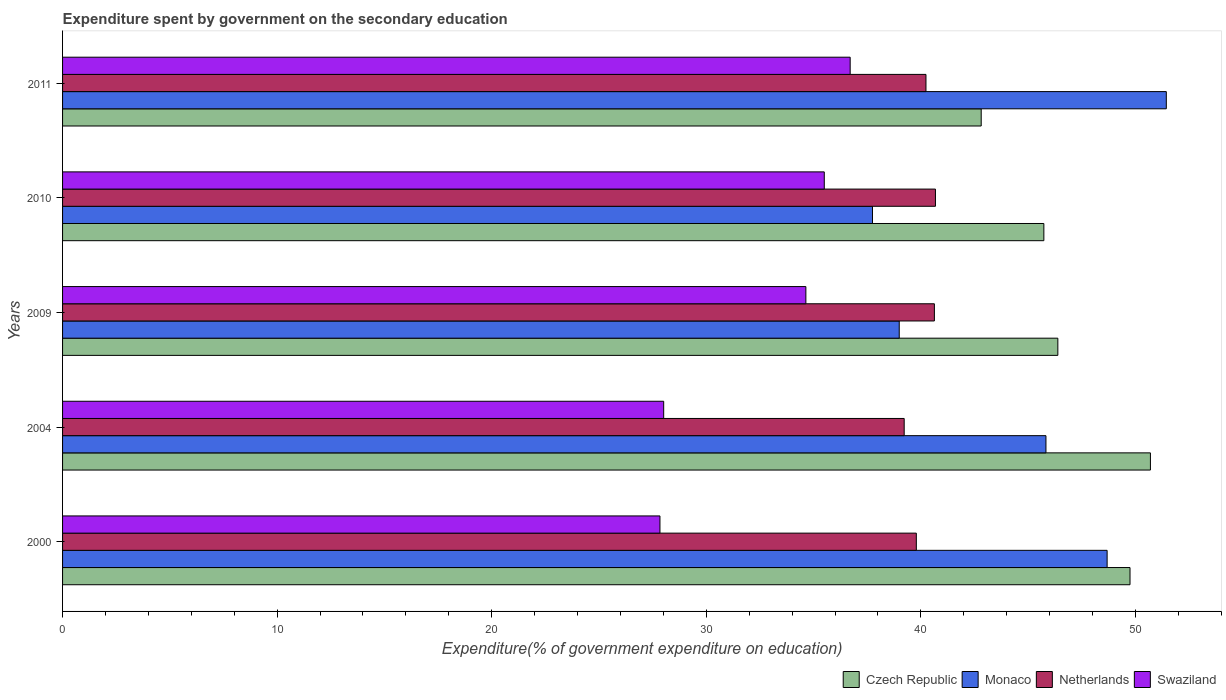How many different coloured bars are there?
Provide a succinct answer. 4. How many groups of bars are there?
Your answer should be compact. 5. Are the number of bars per tick equal to the number of legend labels?
Give a very brief answer. Yes. Are the number of bars on each tick of the Y-axis equal?
Keep it short and to the point. Yes. What is the label of the 2nd group of bars from the top?
Offer a very short reply. 2010. What is the expenditure spent by government on the secondary education in Czech Republic in 2011?
Your answer should be compact. 42.81. Across all years, what is the maximum expenditure spent by government on the secondary education in Netherlands?
Give a very brief answer. 40.68. Across all years, what is the minimum expenditure spent by government on the secondary education in Swaziland?
Your answer should be compact. 27.84. What is the total expenditure spent by government on the secondary education in Netherlands in the graph?
Provide a succinct answer. 200.57. What is the difference between the expenditure spent by government on the secondary education in Monaco in 2004 and that in 2010?
Ensure brevity in your answer.  8.08. What is the difference between the expenditure spent by government on the secondary education in Netherlands in 2004 and the expenditure spent by government on the secondary education in Monaco in 2009?
Make the answer very short. 0.23. What is the average expenditure spent by government on the secondary education in Czech Republic per year?
Make the answer very short. 47.08. In the year 2004, what is the difference between the expenditure spent by government on the secondary education in Czech Republic and expenditure spent by government on the secondary education in Swaziland?
Provide a short and direct response. 22.68. What is the ratio of the expenditure spent by government on the secondary education in Monaco in 2004 to that in 2009?
Keep it short and to the point. 1.18. Is the expenditure spent by government on the secondary education in Netherlands in 2000 less than that in 2004?
Ensure brevity in your answer.  No. Is the difference between the expenditure spent by government on the secondary education in Czech Republic in 2010 and 2011 greater than the difference between the expenditure spent by government on the secondary education in Swaziland in 2010 and 2011?
Provide a short and direct response. Yes. What is the difference between the highest and the second highest expenditure spent by government on the secondary education in Swaziland?
Offer a very short reply. 1.21. What is the difference between the highest and the lowest expenditure spent by government on the secondary education in Swaziland?
Make the answer very short. 8.87. In how many years, is the expenditure spent by government on the secondary education in Swaziland greater than the average expenditure spent by government on the secondary education in Swaziland taken over all years?
Make the answer very short. 3. Is the sum of the expenditure spent by government on the secondary education in Monaco in 2000 and 2004 greater than the maximum expenditure spent by government on the secondary education in Netherlands across all years?
Make the answer very short. Yes. Is it the case that in every year, the sum of the expenditure spent by government on the secondary education in Netherlands and expenditure spent by government on the secondary education in Czech Republic is greater than the sum of expenditure spent by government on the secondary education in Monaco and expenditure spent by government on the secondary education in Swaziland?
Keep it short and to the point. Yes. What does the 1st bar from the top in 2011 represents?
Offer a terse response. Swaziland. What does the 1st bar from the bottom in 2004 represents?
Provide a succinct answer. Czech Republic. How many bars are there?
Ensure brevity in your answer.  20. Are all the bars in the graph horizontal?
Offer a very short reply. Yes. What is the difference between two consecutive major ticks on the X-axis?
Ensure brevity in your answer.  10. How many legend labels are there?
Provide a short and direct response. 4. How are the legend labels stacked?
Ensure brevity in your answer.  Horizontal. What is the title of the graph?
Your answer should be compact. Expenditure spent by government on the secondary education. Does "Canada" appear as one of the legend labels in the graph?
Provide a succinct answer. No. What is the label or title of the X-axis?
Provide a short and direct response. Expenditure(% of government expenditure on education). What is the Expenditure(% of government expenditure on education) of Czech Republic in 2000?
Your answer should be compact. 49.75. What is the Expenditure(% of government expenditure on education) in Monaco in 2000?
Give a very brief answer. 48.68. What is the Expenditure(% of government expenditure on education) in Netherlands in 2000?
Provide a short and direct response. 39.79. What is the Expenditure(% of government expenditure on education) of Swaziland in 2000?
Provide a short and direct response. 27.84. What is the Expenditure(% of government expenditure on education) of Czech Republic in 2004?
Provide a succinct answer. 50.7. What is the Expenditure(% of government expenditure on education) of Monaco in 2004?
Ensure brevity in your answer.  45.83. What is the Expenditure(% of government expenditure on education) of Netherlands in 2004?
Your answer should be very brief. 39.22. What is the Expenditure(% of government expenditure on education) of Swaziland in 2004?
Provide a succinct answer. 28.02. What is the Expenditure(% of government expenditure on education) in Czech Republic in 2009?
Your response must be concise. 46.39. What is the Expenditure(% of government expenditure on education) of Monaco in 2009?
Offer a terse response. 38.99. What is the Expenditure(% of government expenditure on education) of Netherlands in 2009?
Give a very brief answer. 40.63. What is the Expenditure(% of government expenditure on education) of Swaziland in 2009?
Your response must be concise. 34.64. What is the Expenditure(% of government expenditure on education) in Czech Republic in 2010?
Give a very brief answer. 45.73. What is the Expenditure(% of government expenditure on education) in Monaco in 2010?
Provide a short and direct response. 37.75. What is the Expenditure(% of government expenditure on education) in Netherlands in 2010?
Keep it short and to the point. 40.68. What is the Expenditure(% of government expenditure on education) in Swaziland in 2010?
Ensure brevity in your answer.  35.5. What is the Expenditure(% of government expenditure on education) in Czech Republic in 2011?
Provide a short and direct response. 42.81. What is the Expenditure(% of government expenditure on education) in Monaco in 2011?
Give a very brief answer. 51.44. What is the Expenditure(% of government expenditure on education) of Netherlands in 2011?
Offer a very short reply. 40.24. What is the Expenditure(% of government expenditure on education) of Swaziland in 2011?
Your answer should be very brief. 36.71. Across all years, what is the maximum Expenditure(% of government expenditure on education) in Czech Republic?
Your answer should be compact. 50.7. Across all years, what is the maximum Expenditure(% of government expenditure on education) of Monaco?
Ensure brevity in your answer.  51.44. Across all years, what is the maximum Expenditure(% of government expenditure on education) in Netherlands?
Provide a succinct answer. 40.68. Across all years, what is the maximum Expenditure(% of government expenditure on education) of Swaziland?
Give a very brief answer. 36.71. Across all years, what is the minimum Expenditure(% of government expenditure on education) of Czech Republic?
Give a very brief answer. 42.81. Across all years, what is the minimum Expenditure(% of government expenditure on education) in Monaco?
Make the answer very short. 37.75. Across all years, what is the minimum Expenditure(% of government expenditure on education) of Netherlands?
Provide a short and direct response. 39.22. Across all years, what is the minimum Expenditure(% of government expenditure on education) in Swaziland?
Keep it short and to the point. 27.84. What is the total Expenditure(% of government expenditure on education) in Czech Republic in the graph?
Provide a short and direct response. 235.38. What is the total Expenditure(% of government expenditure on education) in Monaco in the graph?
Your answer should be compact. 222.69. What is the total Expenditure(% of government expenditure on education) of Netherlands in the graph?
Provide a succinct answer. 200.57. What is the total Expenditure(% of government expenditure on education) in Swaziland in the graph?
Your answer should be very brief. 162.71. What is the difference between the Expenditure(% of government expenditure on education) in Czech Republic in 2000 and that in 2004?
Your answer should be very brief. -0.95. What is the difference between the Expenditure(% of government expenditure on education) in Monaco in 2000 and that in 2004?
Your answer should be compact. 2.85. What is the difference between the Expenditure(% of government expenditure on education) of Netherlands in 2000 and that in 2004?
Offer a terse response. 0.57. What is the difference between the Expenditure(% of government expenditure on education) of Swaziland in 2000 and that in 2004?
Ensure brevity in your answer.  -0.17. What is the difference between the Expenditure(% of government expenditure on education) in Czech Republic in 2000 and that in 2009?
Keep it short and to the point. 3.36. What is the difference between the Expenditure(% of government expenditure on education) of Monaco in 2000 and that in 2009?
Give a very brief answer. 9.69. What is the difference between the Expenditure(% of government expenditure on education) in Netherlands in 2000 and that in 2009?
Make the answer very short. -0.84. What is the difference between the Expenditure(% of government expenditure on education) in Swaziland in 2000 and that in 2009?
Offer a very short reply. -6.8. What is the difference between the Expenditure(% of government expenditure on education) of Czech Republic in 2000 and that in 2010?
Your answer should be compact. 4.02. What is the difference between the Expenditure(% of government expenditure on education) of Monaco in 2000 and that in 2010?
Offer a terse response. 10.94. What is the difference between the Expenditure(% of government expenditure on education) in Netherlands in 2000 and that in 2010?
Keep it short and to the point. -0.89. What is the difference between the Expenditure(% of government expenditure on education) of Swaziland in 2000 and that in 2010?
Keep it short and to the point. -7.66. What is the difference between the Expenditure(% of government expenditure on education) of Czech Republic in 2000 and that in 2011?
Your response must be concise. 6.94. What is the difference between the Expenditure(% of government expenditure on education) in Monaco in 2000 and that in 2011?
Offer a terse response. -2.76. What is the difference between the Expenditure(% of government expenditure on education) in Netherlands in 2000 and that in 2011?
Give a very brief answer. -0.45. What is the difference between the Expenditure(% of government expenditure on education) of Swaziland in 2000 and that in 2011?
Offer a very short reply. -8.87. What is the difference between the Expenditure(% of government expenditure on education) of Czech Republic in 2004 and that in 2009?
Give a very brief answer. 4.31. What is the difference between the Expenditure(% of government expenditure on education) in Monaco in 2004 and that in 2009?
Provide a succinct answer. 6.84. What is the difference between the Expenditure(% of government expenditure on education) of Netherlands in 2004 and that in 2009?
Keep it short and to the point. -1.41. What is the difference between the Expenditure(% of government expenditure on education) of Swaziland in 2004 and that in 2009?
Provide a short and direct response. -6.63. What is the difference between the Expenditure(% of government expenditure on education) of Czech Republic in 2004 and that in 2010?
Your answer should be very brief. 4.97. What is the difference between the Expenditure(% of government expenditure on education) in Monaco in 2004 and that in 2010?
Offer a terse response. 8.08. What is the difference between the Expenditure(% of government expenditure on education) of Netherlands in 2004 and that in 2010?
Your answer should be very brief. -1.46. What is the difference between the Expenditure(% of government expenditure on education) of Swaziland in 2004 and that in 2010?
Make the answer very short. -7.48. What is the difference between the Expenditure(% of government expenditure on education) of Czech Republic in 2004 and that in 2011?
Provide a succinct answer. 7.89. What is the difference between the Expenditure(% of government expenditure on education) of Monaco in 2004 and that in 2011?
Your answer should be compact. -5.61. What is the difference between the Expenditure(% of government expenditure on education) in Netherlands in 2004 and that in 2011?
Offer a terse response. -1.01. What is the difference between the Expenditure(% of government expenditure on education) of Swaziland in 2004 and that in 2011?
Offer a terse response. -8.69. What is the difference between the Expenditure(% of government expenditure on education) in Czech Republic in 2009 and that in 2010?
Make the answer very short. 0.65. What is the difference between the Expenditure(% of government expenditure on education) in Monaco in 2009 and that in 2010?
Give a very brief answer. 1.25. What is the difference between the Expenditure(% of government expenditure on education) in Netherlands in 2009 and that in 2010?
Provide a succinct answer. -0.05. What is the difference between the Expenditure(% of government expenditure on education) of Swaziland in 2009 and that in 2010?
Ensure brevity in your answer.  -0.86. What is the difference between the Expenditure(% of government expenditure on education) in Czech Republic in 2009 and that in 2011?
Give a very brief answer. 3.57. What is the difference between the Expenditure(% of government expenditure on education) of Monaco in 2009 and that in 2011?
Your answer should be very brief. -12.45. What is the difference between the Expenditure(% of government expenditure on education) of Netherlands in 2009 and that in 2011?
Keep it short and to the point. 0.39. What is the difference between the Expenditure(% of government expenditure on education) of Swaziland in 2009 and that in 2011?
Your response must be concise. -2.06. What is the difference between the Expenditure(% of government expenditure on education) of Czech Republic in 2010 and that in 2011?
Give a very brief answer. 2.92. What is the difference between the Expenditure(% of government expenditure on education) in Monaco in 2010 and that in 2011?
Make the answer very short. -13.69. What is the difference between the Expenditure(% of government expenditure on education) in Netherlands in 2010 and that in 2011?
Offer a terse response. 0.44. What is the difference between the Expenditure(% of government expenditure on education) of Swaziland in 2010 and that in 2011?
Ensure brevity in your answer.  -1.21. What is the difference between the Expenditure(% of government expenditure on education) in Czech Republic in 2000 and the Expenditure(% of government expenditure on education) in Monaco in 2004?
Your answer should be very brief. 3.92. What is the difference between the Expenditure(% of government expenditure on education) in Czech Republic in 2000 and the Expenditure(% of government expenditure on education) in Netherlands in 2004?
Offer a very short reply. 10.52. What is the difference between the Expenditure(% of government expenditure on education) in Czech Republic in 2000 and the Expenditure(% of government expenditure on education) in Swaziland in 2004?
Keep it short and to the point. 21.73. What is the difference between the Expenditure(% of government expenditure on education) of Monaco in 2000 and the Expenditure(% of government expenditure on education) of Netherlands in 2004?
Give a very brief answer. 9.46. What is the difference between the Expenditure(% of government expenditure on education) of Monaco in 2000 and the Expenditure(% of government expenditure on education) of Swaziland in 2004?
Provide a succinct answer. 20.67. What is the difference between the Expenditure(% of government expenditure on education) of Netherlands in 2000 and the Expenditure(% of government expenditure on education) of Swaziland in 2004?
Ensure brevity in your answer.  11.77. What is the difference between the Expenditure(% of government expenditure on education) in Czech Republic in 2000 and the Expenditure(% of government expenditure on education) in Monaco in 2009?
Provide a succinct answer. 10.76. What is the difference between the Expenditure(% of government expenditure on education) of Czech Republic in 2000 and the Expenditure(% of government expenditure on education) of Netherlands in 2009?
Give a very brief answer. 9.12. What is the difference between the Expenditure(% of government expenditure on education) of Czech Republic in 2000 and the Expenditure(% of government expenditure on education) of Swaziland in 2009?
Offer a very short reply. 15.11. What is the difference between the Expenditure(% of government expenditure on education) in Monaco in 2000 and the Expenditure(% of government expenditure on education) in Netherlands in 2009?
Keep it short and to the point. 8.05. What is the difference between the Expenditure(% of government expenditure on education) of Monaco in 2000 and the Expenditure(% of government expenditure on education) of Swaziland in 2009?
Your response must be concise. 14.04. What is the difference between the Expenditure(% of government expenditure on education) in Netherlands in 2000 and the Expenditure(% of government expenditure on education) in Swaziland in 2009?
Provide a succinct answer. 5.15. What is the difference between the Expenditure(% of government expenditure on education) in Czech Republic in 2000 and the Expenditure(% of government expenditure on education) in Monaco in 2010?
Provide a succinct answer. 12. What is the difference between the Expenditure(% of government expenditure on education) of Czech Republic in 2000 and the Expenditure(% of government expenditure on education) of Netherlands in 2010?
Provide a short and direct response. 9.07. What is the difference between the Expenditure(% of government expenditure on education) in Czech Republic in 2000 and the Expenditure(% of government expenditure on education) in Swaziland in 2010?
Make the answer very short. 14.25. What is the difference between the Expenditure(% of government expenditure on education) of Monaco in 2000 and the Expenditure(% of government expenditure on education) of Netherlands in 2010?
Offer a terse response. 8. What is the difference between the Expenditure(% of government expenditure on education) in Monaco in 2000 and the Expenditure(% of government expenditure on education) in Swaziland in 2010?
Provide a short and direct response. 13.18. What is the difference between the Expenditure(% of government expenditure on education) of Netherlands in 2000 and the Expenditure(% of government expenditure on education) of Swaziland in 2010?
Your answer should be compact. 4.29. What is the difference between the Expenditure(% of government expenditure on education) of Czech Republic in 2000 and the Expenditure(% of government expenditure on education) of Monaco in 2011?
Offer a terse response. -1.69. What is the difference between the Expenditure(% of government expenditure on education) of Czech Republic in 2000 and the Expenditure(% of government expenditure on education) of Netherlands in 2011?
Your response must be concise. 9.51. What is the difference between the Expenditure(% of government expenditure on education) in Czech Republic in 2000 and the Expenditure(% of government expenditure on education) in Swaziland in 2011?
Give a very brief answer. 13.04. What is the difference between the Expenditure(% of government expenditure on education) of Monaco in 2000 and the Expenditure(% of government expenditure on education) of Netherlands in 2011?
Make the answer very short. 8.44. What is the difference between the Expenditure(% of government expenditure on education) in Monaco in 2000 and the Expenditure(% of government expenditure on education) in Swaziland in 2011?
Offer a terse response. 11.98. What is the difference between the Expenditure(% of government expenditure on education) of Netherlands in 2000 and the Expenditure(% of government expenditure on education) of Swaziland in 2011?
Your response must be concise. 3.08. What is the difference between the Expenditure(% of government expenditure on education) in Czech Republic in 2004 and the Expenditure(% of government expenditure on education) in Monaco in 2009?
Your response must be concise. 11.71. What is the difference between the Expenditure(% of government expenditure on education) of Czech Republic in 2004 and the Expenditure(% of government expenditure on education) of Netherlands in 2009?
Make the answer very short. 10.07. What is the difference between the Expenditure(% of government expenditure on education) in Czech Republic in 2004 and the Expenditure(% of government expenditure on education) in Swaziland in 2009?
Give a very brief answer. 16.06. What is the difference between the Expenditure(% of government expenditure on education) in Monaco in 2004 and the Expenditure(% of government expenditure on education) in Netherlands in 2009?
Offer a very short reply. 5.2. What is the difference between the Expenditure(% of government expenditure on education) of Monaco in 2004 and the Expenditure(% of government expenditure on education) of Swaziland in 2009?
Provide a short and direct response. 11.19. What is the difference between the Expenditure(% of government expenditure on education) in Netherlands in 2004 and the Expenditure(% of government expenditure on education) in Swaziland in 2009?
Provide a short and direct response. 4.58. What is the difference between the Expenditure(% of government expenditure on education) of Czech Republic in 2004 and the Expenditure(% of government expenditure on education) of Monaco in 2010?
Provide a succinct answer. 12.95. What is the difference between the Expenditure(% of government expenditure on education) of Czech Republic in 2004 and the Expenditure(% of government expenditure on education) of Netherlands in 2010?
Keep it short and to the point. 10.02. What is the difference between the Expenditure(% of government expenditure on education) of Czech Republic in 2004 and the Expenditure(% of government expenditure on education) of Swaziland in 2010?
Your response must be concise. 15.2. What is the difference between the Expenditure(% of government expenditure on education) in Monaco in 2004 and the Expenditure(% of government expenditure on education) in Netherlands in 2010?
Give a very brief answer. 5.15. What is the difference between the Expenditure(% of government expenditure on education) in Monaco in 2004 and the Expenditure(% of government expenditure on education) in Swaziland in 2010?
Your answer should be compact. 10.33. What is the difference between the Expenditure(% of government expenditure on education) in Netherlands in 2004 and the Expenditure(% of government expenditure on education) in Swaziland in 2010?
Your answer should be very brief. 3.72. What is the difference between the Expenditure(% of government expenditure on education) in Czech Republic in 2004 and the Expenditure(% of government expenditure on education) in Monaco in 2011?
Your response must be concise. -0.74. What is the difference between the Expenditure(% of government expenditure on education) of Czech Republic in 2004 and the Expenditure(% of government expenditure on education) of Netherlands in 2011?
Your response must be concise. 10.46. What is the difference between the Expenditure(% of government expenditure on education) in Czech Republic in 2004 and the Expenditure(% of government expenditure on education) in Swaziland in 2011?
Offer a very short reply. 13.99. What is the difference between the Expenditure(% of government expenditure on education) of Monaco in 2004 and the Expenditure(% of government expenditure on education) of Netherlands in 2011?
Make the answer very short. 5.59. What is the difference between the Expenditure(% of government expenditure on education) in Monaco in 2004 and the Expenditure(% of government expenditure on education) in Swaziland in 2011?
Offer a very short reply. 9.12. What is the difference between the Expenditure(% of government expenditure on education) of Netherlands in 2004 and the Expenditure(% of government expenditure on education) of Swaziland in 2011?
Provide a succinct answer. 2.52. What is the difference between the Expenditure(% of government expenditure on education) in Czech Republic in 2009 and the Expenditure(% of government expenditure on education) in Monaco in 2010?
Offer a very short reply. 8.64. What is the difference between the Expenditure(% of government expenditure on education) of Czech Republic in 2009 and the Expenditure(% of government expenditure on education) of Netherlands in 2010?
Offer a terse response. 5.7. What is the difference between the Expenditure(% of government expenditure on education) of Czech Republic in 2009 and the Expenditure(% of government expenditure on education) of Swaziland in 2010?
Ensure brevity in your answer.  10.89. What is the difference between the Expenditure(% of government expenditure on education) in Monaco in 2009 and the Expenditure(% of government expenditure on education) in Netherlands in 2010?
Your answer should be very brief. -1.69. What is the difference between the Expenditure(% of government expenditure on education) of Monaco in 2009 and the Expenditure(% of government expenditure on education) of Swaziland in 2010?
Make the answer very short. 3.49. What is the difference between the Expenditure(% of government expenditure on education) of Netherlands in 2009 and the Expenditure(% of government expenditure on education) of Swaziland in 2010?
Your answer should be very brief. 5.13. What is the difference between the Expenditure(% of government expenditure on education) of Czech Republic in 2009 and the Expenditure(% of government expenditure on education) of Monaco in 2011?
Your answer should be very brief. -5.05. What is the difference between the Expenditure(% of government expenditure on education) in Czech Republic in 2009 and the Expenditure(% of government expenditure on education) in Netherlands in 2011?
Your answer should be very brief. 6.15. What is the difference between the Expenditure(% of government expenditure on education) of Czech Republic in 2009 and the Expenditure(% of government expenditure on education) of Swaziland in 2011?
Ensure brevity in your answer.  9.68. What is the difference between the Expenditure(% of government expenditure on education) of Monaco in 2009 and the Expenditure(% of government expenditure on education) of Netherlands in 2011?
Provide a short and direct response. -1.25. What is the difference between the Expenditure(% of government expenditure on education) in Monaco in 2009 and the Expenditure(% of government expenditure on education) in Swaziland in 2011?
Offer a terse response. 2.29. What is the difference between the Expenditure(% of government expenditure on education) of Netherlands in 2009 and the Expenditure(% of government expenditure on education) of Swaziland in 2011?
Your answer should be very brief. 3.93. What is the difference between the Expenditure(% of government expenditure on education) of Czech Republic in 2010 and the Expenditure(% of government expenditure on education) of Monaco in 2011?
Make the answer very short. -5.71. What is the difference between the Expenditure(% of government expenditure on education) of Czech Republic in 2010 and the Expenditure(% of government expenditure on education) of Netherlands in 2011?
Make the answer very short. 5.49. What is the difference between the Expenditure(% of government expenditure on education) in Czech Republic in 2010 and the Expenditure(% of government expenditure on education) in Swaziland in 2011?
Provide a short and direct response. 9.03. What is the difference between the Expenditure(% of government expenditure on education) of Monaco in 2010 and the Expenditure(% of government expenditure on education) of Netherlands in 2011?
Make the answer very short. -2.49. What is the difference between the Expenditure(% of government expenditure on education) in Monaco in 2010 and the Expenditure(% of government expenditure on education) in Swaziland in 2011?
Ensure brevity in your answer.  1.04. What is the difference between the Expenditure(% of government expenditure on education) of Netherlands in 2010 and the Expenditure(% of government expenditure on education) of Swaziland in 2011?
Your answer should be very brief. 3.97. What is the average Expenditure(% of government expenditure on education) of Czech Republic per year?
Make the answer very short. 47.08. What is the average Expenditure(% of government expenditure on education) of Monaco per year?
Your answer should be compact. 44.54. What is the average Expenditure(% of government expenditure on education) in Netherlands per year?
Give a very brief answer. 40.11. What is the average Expenditure(% of government expenditure on education) in Swaziland per year?
Offer a very short reply. 32.54. In the year 2000, what is the difference between the Expenditure(% of government expenditure on education) in Czech Republic and Expenditure(% of government expenditure on education) in Monaco?
Your answer should be compact. 1.07. In the year 2000, what is the difference between the Expenditure(% of government expenditure on education) of Czech Republic and Expenditure(% of government expenditure on education) of Netherlands?
Ensure brevity in your answer.  9.96. In the year 2000, what is the difference between the Expenditure(% of government expenditure on education) of Czech Republic and Expenditure(% of government expenditure on education) of Swaziland?
Your response must be concise. 21.91. In the year 2000, what is the difference between the Expenditure(% of government expenditure on education) of Monaco and Expenditure(% of government expenditure on education) of Netherlands?
Your response must be concise. 8.89. In the year 2000, what is the difference between the Expenditure(% of government expenditure on education) of Monaco and Expenditure(% of government expenditure on education) of Swaziland?
Offer a very short reply. 20.84. In the year 2000, what is the difference between the Expenditure(% of government expenditure on education) in Netherlands and Expenditure(% of government expenditure on education) in Swaziland?
Give a very brief answer. 11.95. In the year 2004, what is the difference between the Expenditure(% of government expenditure on education) in Czech Republic and Expenditure(% of government expenditure on education) in Monaco?
Your response must be concise. 4.87. In the year 2004, what is the difference between the Expenditure(% of government expenditure on education) in Czech Republic and Expenditure(% of government expenditure on education) in Netherlands?
Keep it short and to the point. 11.48. In the year 2004, what is the difference between the Expenditure(% of government expenditure on education) in Czech Republic and Expenditure(% of government expenditure on education) in Swaziland?
Your answer should be very brief. 22.68. In the year 2004, what is the difference between the Expenditure(% of government expenditure on education) in Monaco and Expenditure(% of government expenditure on education) in Netherlands?
Keep it short and to the point. 6.61. In the year 2004, what is the difference between the Expenditure(% of government expenditure on education) in Monaco and Expenditure(% of government expenditure on education) in Swaziland?
Ensure brevity in your answer.  17.82. In the year 2004, what is the difference between the Expenditure(% of government expenditure on education) of Netherlands and Expenditure(% of government expenditure on education) of Swaziland?
Keep it short and to the point. 11.21. In the year 2009, what is the difference between the Expenditure(% of government expenditure on education) in Czech Republic and Expenditure(% of government expenditure on education) in Monaco?
Keep it short and to the point. 7.39. In the year 2009, what is the difference between the Expenditure(% of government expenditure on education) in Czech Republic and Expenditure(% of government expenditure on education) in Netherlands?
Provide a succinct answer. 5.75. In the year 2009, what is the difference between the Expenditure(% of government expenditure on education) of Czech Republic and Expenditure(% of government expenditure on education) of Swaziland?
Your response must be concise. 11.74. In the year 2009, what is the difference between the Expenditure(% of government expenditure on education) in Monaco and Expenditure(% of government expenditure on education) in Netherlands?
Your response must be concise. -1.64. In the year 2009, what is the difference between the Expenditure(% of government expenditure on education) of Monaco and Expenditure(% of government expenditure on education) of Swaziland?
Your response must be concise. 4.35. In the year 2009, what is the difference between the Expenditure(% of government expenditure on education) in Netherlands and Expenditure(% of government expenditure on education) in Swaziland?
Make the answer very short. 5.99. In the year 2010, what is the difference between the Expenditure(% of government expenditure on education) of Czech Republic and Expenditure(% of government expenditure on education) of Monaco?
Your response must be concise. 7.99. In the year 2010, what is the difference between the Expenditure(% of government expenditure on education) of Czech Republic and Expenditure(% of government expenditure on education) of Netherlands?
Provide a short and direct response. 5.05. In the year 2010, what is the difference between the Expenditure(% of government expenditure on education) of Czech Republic and Expenditure(% of government expenditure on education) of Swaziland?
Provide a short and direct response. 10.23. In the year 2010, what is the difference between the Expenditure(% of government expenditure on education) in Monaco and Expenditure(% of government expenditure on education) in Netherlands?
Make the answer very short. -2.93. In the year 2010, what is the difference between the Expenditure(% of government expenditure on education) in Monaco and Expenditure(% of government expenditure on education) in Swaziland?
Your answer should be compact. 2.25. In the year 2010, what is the difference between the Expenditure(% of government expenditure on education) of Netherlands and Expenditure(% of government expenditure on education) of Swaziland?
Keep it short and to the point. 5.18. In the year 2011, what is the difference between the Expenditure(% of government expenditure on education) of Czech Republic and Expenditure(% of government expenditure on education) of Monaco?
Provide a succinct answer. -8.63. In the year 2011, what is the difference between the Expenditure(% of government expenditure on education) of Czech Republic and Expenditure(% of government expenditure on education) of Netherlands?
Ensure brevity in your answer.  2.57. In the year 2011, what is the difference between the Expenditure(% of government expenditure on education) of Czech Republic and Expenditure(% of government expenditure on education) of Swaziland?
Your answer should be very brief. 6.11. In the year 2011, what is the difference between the Expenditure(% of government expenditure on education) in Monaco and Expenditure(% of government expenditure on education) in Netherlands?
Offer a terse response. 11.2. In the year 2011, what is the difference between the Expenditure(% of government expenditure on education) in Monaco and Expenditure(% of government expenditure on education) in Swaziland?
Your response must be concise. 14.73. In the year 2011, what is the difference between the Expenditure(% of government expenditure on education) in Netherlands and Expenditure(% of government expenditure on education) in Swaziland?
Your response must be concise. 3.53. What is the ratio of the Expenditure(% of government expenditure on education) in Czech Republic in 2000 to that in 2004?
Provide a short and direct response. 0.98. What is the ratio of the Expenditure(% of government expenditure on education) in Monaco in 2000 to that in 2004?
Offer a terse response. 1.06. What is the ratio of the Expenditure(% of government expenditure on education) in Netherlands in 2000 to that in 2004?
Ensure brevity in your answer.  1.01. What is the ratio of the Expenditure(% of government expenditure on education) in Czech Republic in 2000 to that in 2009?
Ensure brevity in your answer.  1.07. What is the ratio of the Expenditure(% of government expenditure on education) of Monaco in 2000 to that in 2009?
Give a very brief answer. 1.25. What is the ratio of the Expenditure(% of government expenditure on education) of Netherlands in 2000 to that in 2009?
Provide a short and direct response. 0.98. What is the ratio of the Expenditure(% of government expenditure on education) of Swaziland in 2000 to that in 2009?
Your answer should be very brief. 0.8. What is the ratio of the Expenditure(% of government expenditure on education) in Czech Republic in 2000 to that in 2010?
Give a very brief answer. 1.09. What is the ratio of the Expenditure(% of government expenditure on education) in Monaco in 2000 to that in 2010?
Your answer should be compact. 1.29. What is the ratio of the Expenditure(% of government expenditure on education) in Netherlands in 2000 to that in 2010?
Your answer should be very brief. 0.98. What is the ratio of the Expenditure(% of government expenditure on education) in Swaziland in 2000 to that in 2010?
Your answer should be very brief. 0.78. What is the ratio of the Expenditure(% of government expenditure on education) of Czech Republic in 2000 to that in 2011?
Provide a succinct answer. 1.16. What is the ratio of the Expenditure(% of government expenditure on education) of Monaco in 2000 to that in 2011?
Provide a succinct answer. 0.95. What is the ratio of the Expenditure(% of government expenditure on education) of Swaziland in 2000 to that in 2011?
Your response must be concise. 0.76. What is the ratio of the Expenditure(% of government expenditure on education) in Czech Republic in 2004 to that in 2009?
Give a very brief answer. 1.09. What is the ratio of the Expenditure(% of government expenditure on education) of Monaco in 2004 to that in 2009?
Your answer should be compact. 1.18. What is the ratio of the Expenditure(% of government expenditure on education) of Netherlands in 2004 to that in 2009?
Give a very brief answer. 0.97. What is the ratio of the Expenditure(% of government expenditure on education) of Swaziland in 2004 to that in 2009?
Provide a succinct answer. 0.81. What is the ratio of the Expenditure(% of government expenditure on education) of Czech Republic in 2004 to that in 2010?
Offer a terse response. 1.11. What is the ratio of the Expenditure(% of government expenditure on education) of Monaco in 2004 to that in 2010?
Ensure brevity in your answer.  1.21. What is the ratio of the Expenditure(% of government expenditure on education) in Netherlands in 2004 to that in 2010?
Your answer should be compact. 0.96. What is the ratio of the Expenditure(% of government expenditure on education) in Swaziland in 2004 to that in 2010?
Your response must be concise. 0.79. What is the ratio of the Expenditure(% of government expenditure on education) of Czech Republic in 2004 to that in 2011?
Give a very brief answer. 1.18. What is the ratio of the Expenditure(% of government expenditure on education) in Monaco in 2004 to that in 2011?
Offer a very short reply. 0.89. What is the ratio of the Expenditure(% of government expenditure on education) of Netherlands in 2004 to that in 2011?
Make the answer very short. 0.97. What is the ratio of the Expenditure(% of government expenditure on education) in Swaziland in 2004 to that in 2011?
Your response must be concise. 0.76. What is the ratio of the Expenditure(% of government expenditure on education) of Czech Republic in 2009 to that in 2010?
Give a very brief answer. 1.01. What is the ratio of the Expenditure(% of government expenditure on education) in Monaco in 2009 to that in 2010?
Your response must be concise. 1.03. What is the ratio of the Expenditure(% of government expenditure on education) in Swaziland in 2009 to that in 2010?
Offer a terse response. 0.98. What is the ratio of the Expenditure(% of government expenditure on education) in Czech Republic in 2009 to that in 2011?
Offer a very short reply. 1.08. What is the ratio of the Expenditure(% of government expenditure on education) of Monaco in 2009 to that in 2011?
Give a very brief answer. 0.76. What is the ratio of the Expenditure(% of government expenditure on education) in Netherlands in 2009 to that in 2011?
Ensure brevity in your answer.  1.01. What is the ratio of the Expenditure(% of government expenditure on education) of Swaziland in 2009 to that in 2011?
Give a very brief answer. 0.94. What is the ratio of the Expenditure(% of government expenditure on education) in Czech Republic in 2010 to that in 2011?
Your answer should be very brief. 1.07. What is the ratio of the Expenditure(% of government expenditure on education) of Monaco in 2010 to that in 2011?
Provide a succinct answer. 0.73. What is the ratio of the Expenditure(% of government expenditure on education) in Swaziland in 2010 to that in 2011?
Your answer should be very brief. 0.97. What is the difference between the highest and the second highest Expenditure(% of government expenditure on education) in Czech Republic?
Make the answer very short. 0.95. What is the difference between the highest and the second highest Expenditure(% of government expenditure on education) of Monaco?
Offer a very short reply. 2.76. What is the difference between the highest and the second highest Expenditure(% of government expenditure on education) in Netherlands?
Ensure brevity in your answer.  0.05. What is the difference between the highest and the second highest Expenditure(% of government expenditure on education) in Swaziland?
Provide a short and direct response. 1.21. What is the difference between the highest and the lowest Expenditure(% of government expenditure on education) of Czech Republic?
Your answer should be very brief. 7.89. What is the difference between the highest and the lowest Expenditure(% of government expenditure on education) in Monaco?
Your answer should be very brief. 13.69. What is the difference between the highest and the lowest Expenditure(% of government expenditure on education) of Netherlands?
Your answer should be compact. 1.46. What is the difference between the highest and the lowest Expenditure(% of government expenditure on education) of Swaziland?
Make the answer very short. 8.87. 